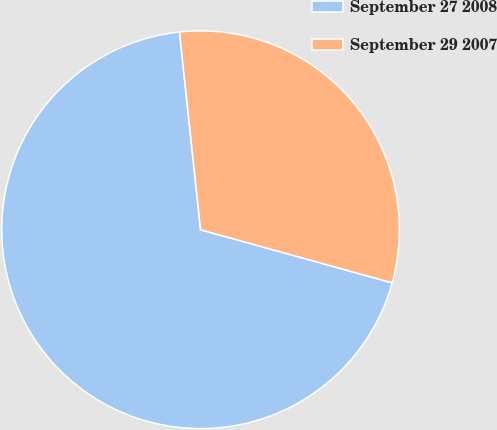<chart> <loc_0><loc_0><loc_500><loc_500><pie_chart><fcel>September 27 2008<fcel>September 29 2007<nl><fcel>69.01%<fcel>30.99%<nl></chart> 